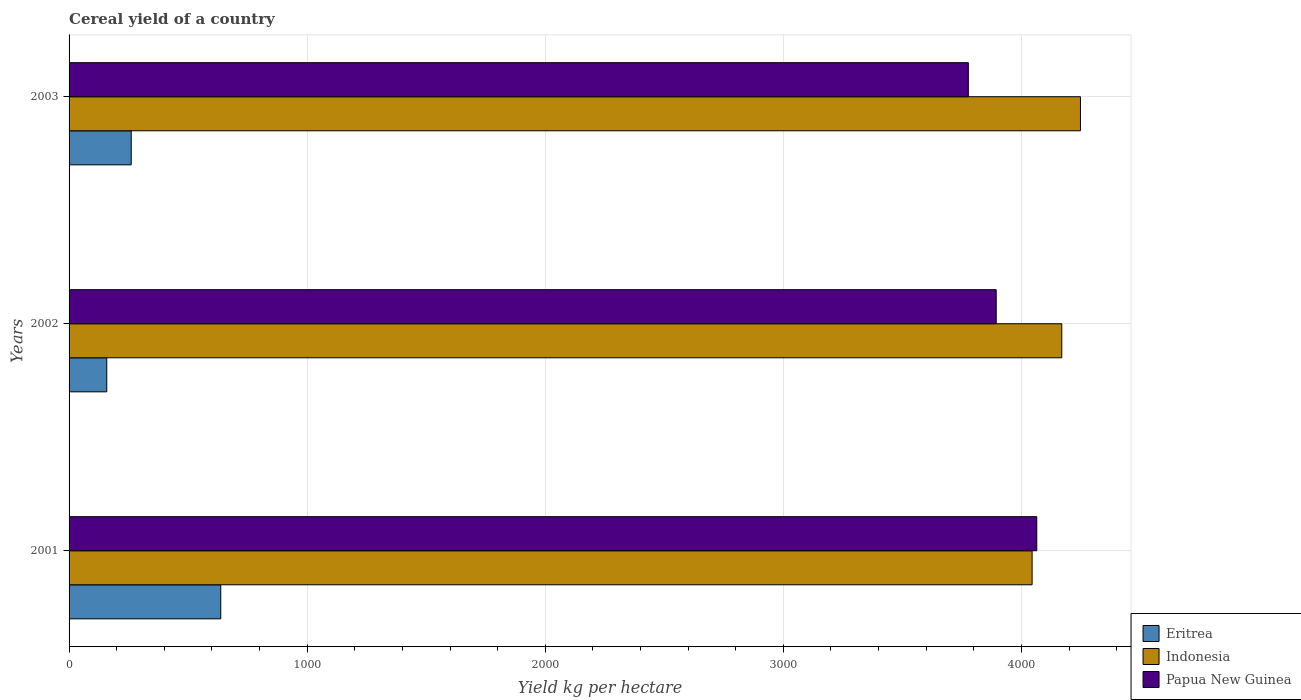How many different coloured bars are there?
Offer a terse response. 3. How many groups of bars are there?
Provide a succinct answer. 3. What is the label of the 2nd group of bars from the top?
Give a very brief answer. 2002. In how many cases, is the number of bars for a given year not equal to the number of legend labels?
Your response must be concise. 0. What is the total cereal yield in Eritrea in 2001?
Provide a succinct answer. 637.09. Across all years, what is the maximum total cereal yield in Indonesia?
Your response must be concise. 4248.09. Across all years, what is the minimum total cereal yield in Eritrea?
Offer a very short reply. 158.23. In which year was the total cereal yield in Papua New Guinea minimum?
Provide a short and direct response. 2003. What is the total total cereal yield in Eritrea in the graph?
Give a very brief answer. 1056.36. What is the difference between the total cereal yield in Eritrea in 2001 and that in 2003?
Ensure brevity in your answer.  376.05. What is the difference between the total cereal yield in Eritrea in 2003 and the total cereal yield in Papua New Guinea in 2002?
Provide a short and direct response. -3633.11. What is the average total cereal yield in Eritrea per year?
Your answer should be very brief. 352.12. In the year 2003, what is the difference between the total cereal yield in Eritrea and total cereal yield in Papua New Guinea?
Give a very brief answer. -3516.01. What is the ratio of the total cereal yield in Indonesia in 2001 to that in 2003?
Your answer should be compact. 0.95. Is the total cereal yield in Indonesia in 2002 less than that in 2003?
Provide a short and direct response. Yes. What is the difference between the highest and the second highest total cereal yield in Eritrea?
Offer a very short reply. 376.05. What is the difference between the highest and the lowest total cereal yield in Eritrea?
Offer a terse response. 478.86. In how many years, is the total cereal yield in Eritrea greater than the average total cereal yield in Eritrea taken over all years?
Make the answer very short. 1. Is the sum of the total cereal yield in Indonesia in 2001 and 2002 greater than the maximum total cereal yield in Papua New Guinea across all years?
Ensure brevity in your answer.  Yes. What does the 1st bar from the top in 2003 represents?
Provide a short and direct response. Papua New Guinea. Is it the case that in every year, the sum of the total cereal yield in Indonesia and total cereal yield in Papua New Guinea is greater than the total cereal yield in Eritrea?
Ensure brevity in your answer.  Yes. How many years are there in the graph?
Offer a terse response. 3. Are the values on the major ticks of X-axis written in scientific E-notation?
Provide a succinct answer. No. How many legend labels are there?
Ensure brevity in your answer.  3. What is the title of the graph?
Make the answer very short. Cereal yield of a country. What is the label or title of the X-axis?
Make the answer very short. Yield kg per hectare. What is the label or title of the Y-axis?
Provide a succinct answer. Years. What is the Yield kg per hectare of Eritrea in 2001?
Offer a terse response. 637.09. What is the Yield kg per hectare in Indonesia in 2001?
Offer a terse response. 4044.93. What is the Yield kg per hectare in Papua New Guinea in 2001?
Your answer should be very brief. 4064.52. What is the Yield kg per hectare in Eritrea in 2002?
Give a very brief answer. 158.23. What is the Yield kg per hectare in Indonesia in 2002?
Offer a terse response. 4169.51. What is the Yield kg per hectare of Papua New Guinea in 2002?
Your response must be concise. 3894.15. What is the Yield kg per hectare in Eritrea in 2003?
Provide a short and direct response. 261.04. What is the Yield kg per hectare in Indonesia in 2003?
Offer a terse response. 4248.09. What is the Yield kg per hectare of Papua New Guinea in 2003?
Keep it short and to the point. 3777.04. Across all years, what is the maximum Yield kg per hectare of Eritrea?
Ensure brevity in your answer.  637.09. Across all years, what is the maximum Yield kg per hectare in Indonesia?
Give a very brief answer. 4248.09. Across all years, what is the maximum Yield kg per hectare of Papua New Guinea?
Keep it short and to the point. 4064.52. Across all years, what is the minimum Yield kg per hectare of Eritrea?
Make the answer very short. 158.23. Across all years, what is the minimum Yield kg per hectare of Indonesia?
Offer a terse response. 4044.93. Across all years, what is the minimum Yield kg per hectare in Papua New Guinea?
Offer a terse response. 3777.04. What is the total Yield kg per hectare of Eritrea in the graph?
Your answer should be very brief. 1056.36. What is the total Yield kg per hectare in Indonesia in the graph?
Your response must be concise. 1.25e+04. What is the total Yield kg per hectare of Papua New Guinea in the graph?
Provide a succinct answer. 1.17e+04. What is the difference between the Yield kg per hectare of Eritrea in 2001 and that in 2002?
Ensure brevity in your answer.  478.86. What is the difference between the Yield kg per hectare in Indonesia in 2001 and that in 2002?
Your answer should be compact. -124.58. What is the difference between the Yield kg per hectare in Papua New Guinea in 2001 and that in 2002?
Offer a terse response. 170.37. What is the difference between the Yield kg per hectare in Eritrea in 2001 and that in 2003?
Your answer should be compact. 376.05. What is the difference between the Yield kg per hectare of Indonesia in 2001 and that in 2003?
Provide a succinct answer. -203.15. What is the difference between the Yield kg per hectare in Papua New Guinea in 2001 and that in 2003?
Give a very brief answer. 287.47. What is the difference between the Yield kg per hectare in Eritrea in 2002 and that in 2003?
Your answer should be compact. -102.81. What is the difference between the Yield kg per hectare of Indonesia in 2002 and that in 2003?
Offer a terse response. -78.58. What is the difference between the Yield kg per hectare of Papua New Guinea in 2002 and that in 2003?
Give a very brief answer. 117.11. What is the difference between the Yield kg per hectare of Eritrea in 2001 and the Yield kg per hectare of Indonesia in 2002?
Your response must be concise. -3532.42. What is the difference between the Yield kg per hectare in Eritrea in 2001 and the Yield kg per hectare in Papua New Guinea in 2002?
Your answer should be compact. -3257.06. What is the difference between the Yield kg per hectare of Indonesia in 2001 and the Yield kg per hectare of Papua New Guinea in 2002?
Your answer should be very brief. 150.78. What is the difference between the Yield kg per hectare in Eritrea in 2001 and the Yield kg per hectare in Indonesia in 2003?
Offer a terse response. -3611. What is the difference between the Yield kg per hectare of Eritrea in 2001 and the Yield kg per hectare of Papua New Guinea in 2003?
Make the answer very short. -3139.95. What is the difference between the Yield kg per hectare of Indonesia in 2001 and the Yield kg per hectare of Papua New Guinea in 2003?
Provide a short and direct response. 267.89. What is the difference between the Yield kg per hectare in Eritrea in 2002 and the Yield kg per hectare in Indonesia in 2003?
Your response must be concise. -4089.86. What is the difference between the Yield kg per hectare in Eritrea in 2002 and the Yield kg per hectare in Papua New Guinea in 2003?
Your answer should be very brief. -3618.82. What is the difference between the Yield kg per hectare of Indonesia in 2002 and the Yield kg per hectare of Papua New Guinea in 2003?
Provide a succinct answer. 392.47. What is the average Yield kg per hectare in Eritrea per year?
Keep it short and to the point. 352.12. What is the average Yield kg per hectare of Indonesia per year?
Provide a succinct answer. 4154.18. What is the average Yield kg per hectare in Papua New Guinea per year?
Your answer should be very brief. 3911.9. In the year 2001, what is the difference between the Yield kg per hectare of Eritrea and Yield kg per hectare of Indonesia?
Ensure brevity in your answer.  -3407.84. In the year 2001, what is the difference between the Yield kg per hectare in Eritrea and Yield kg per hectare in Papua New Guinea?
Your answer should be very brief. -3427.43. In the year 2001, what is the difference between the Yield kg per hectare of Indonesia and Yield kg per hectare of Papua New Guinea?
Ensure brevity in your answer.  -19.58. In the year 2002, what is the difference between the Yield kg per hectare of Eritrea and Yield kg per hectare of Indonesia?
Offer a terse response. -4011.28. In the year 2002, what is the difference between the Yield kg per hectare in Eritrea and Yield kg per hectare in Papua New Guinea?
Provide a short and direct response. -3735.92. In the year 2002, what is the difference between the Yield kg per hectare of Indonesia and Yield kg per hectare of Papua New Guinea?
Your answer should be very brief. 275.36. In the year 2003, what is the difference between the Yield kg per hectare in Eritrea and Yield kg per hectare in Indonesia?
Make the answer very short. -3987.05. In the year 2003, what is the difference between the Yield kg per hectare in Eritrea and Yield kg per hectare in Papua New Guinea?
Your response must be concise. -3516.01. In the year 2003, what is the difference between the Yield kg per hectare of Indonesia and Yield kg per hectare of Papua New Guinea?
Your response must be concise. 471.04. What is the ratio of the Yield kg per hectare in Eritrea in 2001 to that in 2002?
Provide a short and direct response. 4.03. What is the ratio of the Yield kg per hectare of Indonesia in 2001 to that in 2002?
Your response must be concise. 0.97. What is the ratio of the Yield kg per hectare of Papua New Guinea in 2001 to that in 2002?
Your answer should be very brief. 1.04. What is the ratio of the Yield kg per hectare in Eritrea in 2001 to that in 2003?
Your answer should be very brief. 2.44. What is the ratio of the Yield kg per hectare in Indonesia in 2001 to that in 2003?
Make the answer very short. 0.95. What is the ratio of the Yield kg per hectare of Papua New Guinea in 2001 to that in 2003?
Provide a short and direct response. 1.08. What is the ratio of the Yield kg per hectare of Eritrea in 2002 to that in 2003?
Make the answer very short. 0.61. What is the ratio of the Yield kg per hectare of Indonesia in 2002 to that in 2003?
Provide a short and direct response. 0.98. What is the ratio of the Yield kg per hectare in Papua New Guinea in 2002 to that in 2003?
Your answer should be compact. 1.03. What is the difference between the highest and the second highest Yield kg per hectare of Eritrea?
Offer a terse response. 376.05. What is the difference between the highest and the second highest Yield kg per hectare of Indonesia?
Provide a short and direct response. 78.58. What is the difference between the highest and the second highest Yield kg per hectare in Papua New Guinea?
Ensure brevity in your answer.  170.37. What is the difference between the highest and the lowest Yield kg per hectare of Eritrea?
Provide a succinct answer. 478.86. What is the difference between the highest and the lowest Yield kg per hectare of Indonesia?
Provide a succinct answer. 203.15. What is the difference between the highest and the lowest Yield kg per hectare in Papua New Guinea?
Give a very brief answer. 287.47. 